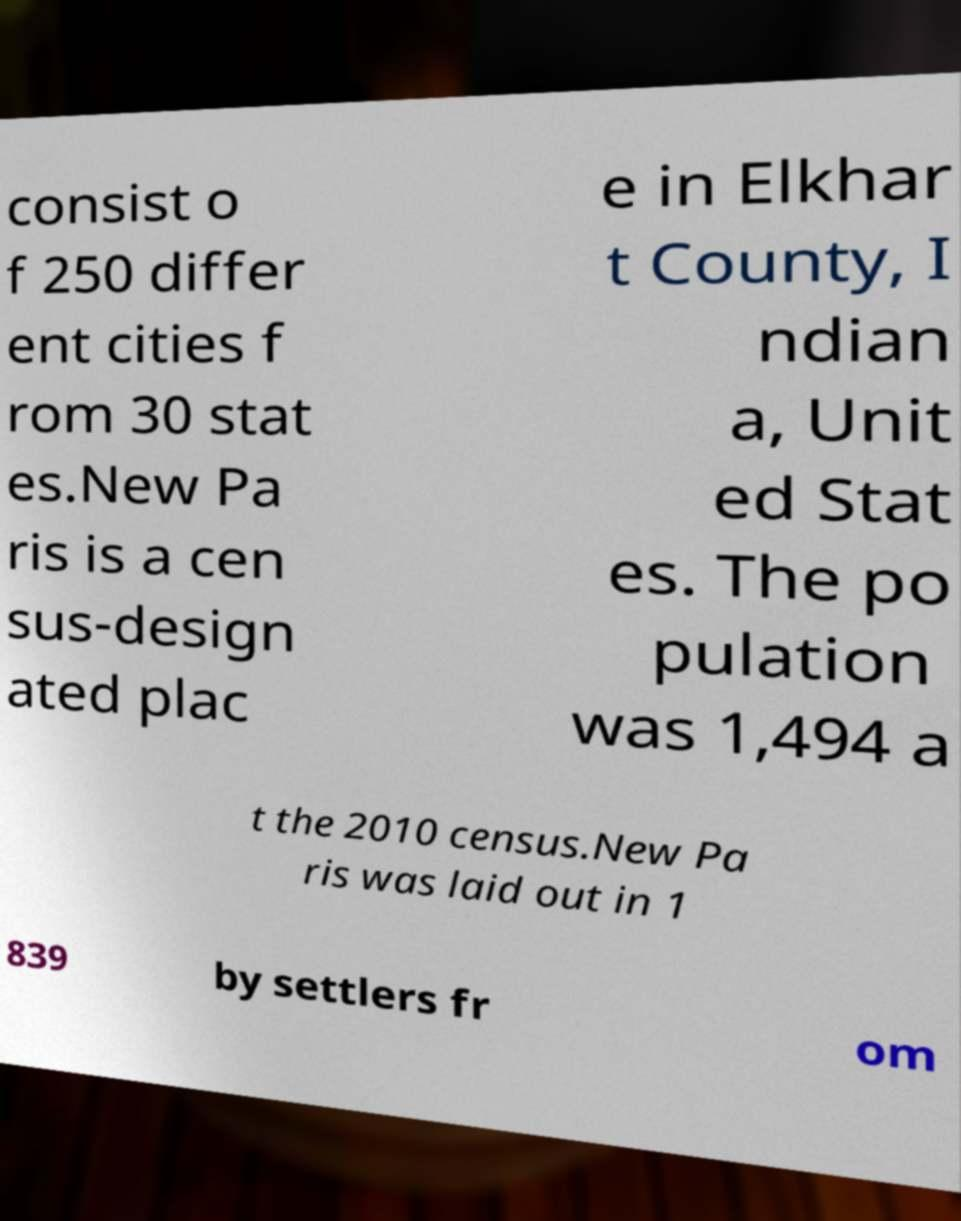Could you assist in decoding the text presented in this image and type it out clearly? consist o f 250 differ ent cities f rom 30 stat es.New Pa ris is a cen sus-design ated plac e in Elkhar t County, I ndian a, Unit ed Stat es. The po pulation was 1,494 a t the 2010 census.New Pa ris was laid out in 1 839 by settlers fr om 